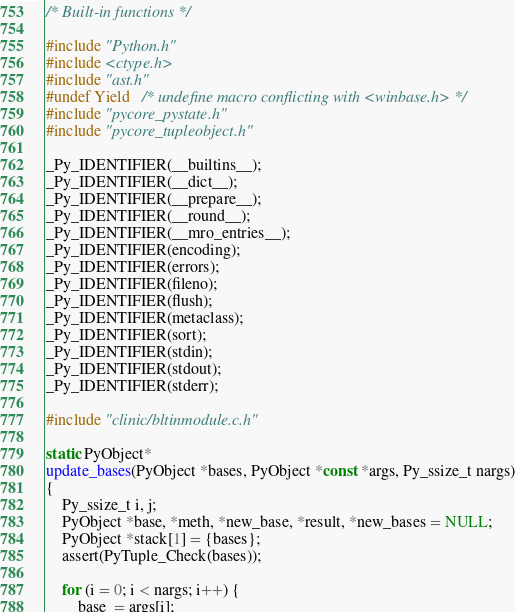Convert code to text. <code><loc_0><loc_0><loc_500><loc_500><_C_>/* Built-in functions */

#include "Python.h"
#include <ctype.h>
#include "ast.h"
#undef Yield   /* undefine macro conflicting with <winbase.h> */
#include "pycore_pystate.h"
#include "pycore_tupleobject.h"

_Py_IDENTIFIER(__builtins__);
_Py_IDENTIFIER(__dict__);
_Py_IDENTIFIER(__prepare__);
_Py_IDENTIFIER(__round__);
_Py_IDENTIFIER(__mro_entries__);
_Py_IDENTIFIER(encoding);
_Py_IDENTIFIER(errors);
_Py_IDENTIFIER(fileno);
_Py_IDENTIFIER(flush);
_Py_IDENTIFIER(metaclass);
_Py_IDENTIFIER(sort);
_Py_IDENTIFIER(stdin);
_Py_IDENTIFIER(stdout);
_Py_IDENTIFIER(stderr);

#include "clinic/bltinmodule.c.h"

static PyObject*
update_bases(PyObject *bases, PyObject *const *args, Py_ssize_t nargs)
{
    Py_ssize_t i, j;
    PyObject *base, *meth, *new_base, *result, *new_bases = NULL;
    PyObject *stack[1] = {bases};
    assert(PyTuple_Check(bases));

    for (i = 0; i < nargs; i++) {
        base  = args[i];</code> 